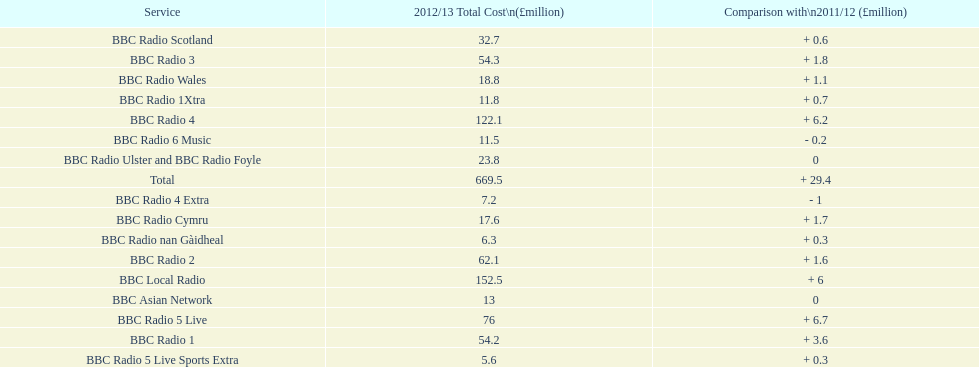Which bbc station had cost the most to run in 2012/13? BBC Local Radio. Could you help me parse every detail presented in this table? {'header': ['Service', '2012/13 Total Cost\\n(£million)', 'Comparison with\\n2011/12 (£million)'], 'rows': [['BBC Radio Scotland', '32.7', '+ 0.6'], ['BBC Radio 3', '54.3', '+ 1.8'], ['BBC Radio Wales', '18.8', '+ 1.1'], ['BBC Radio 1Xtra', '11.8', '+ 0.7'], ['BBC Radio 4', '122.1', '+ 6.2'], ['BBC Radio 6 Music', '11.5', '- 0.2'], ['BBC Radio Ulster and BBC Radio Foyle', '23.8', '0'], ['Total', '669.5', '+ 29.4'], ['BBC Radio 4 Extra', '7.2', '- 1'], ['BBC Radio Cymru', '17.6', '+ 1.7'], ['BBC Radio nan Gàidheal', '6.3', '+ 0.3'], ['BBC Radio 2', '62.1', '+ 1.6'], ['BBC Local Radio', '152.5', '+ 6'], ['BBC Asian Network', '13', '0'], ['BBC Radio 5 Live', '76', '+ 6.7'], ['BBC Radio 1', '54.2', '+ 3.6'], ['BBC Radio 5 Live Sports Extra', '5.6', '+ 0.3']]} 